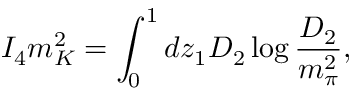Convert formula to latex. <formula><loc_0><loc_0><loc_500><loc_500>I _ { 4 } m _ { K } ^ { 2 } = \int _ { 0 } ^ { 1 } d z _ { 1 } D _ { 2 } \log { \frac { D _ { 2 } } { m _ { \pi } ^ { 2 } } } ,</formula> 